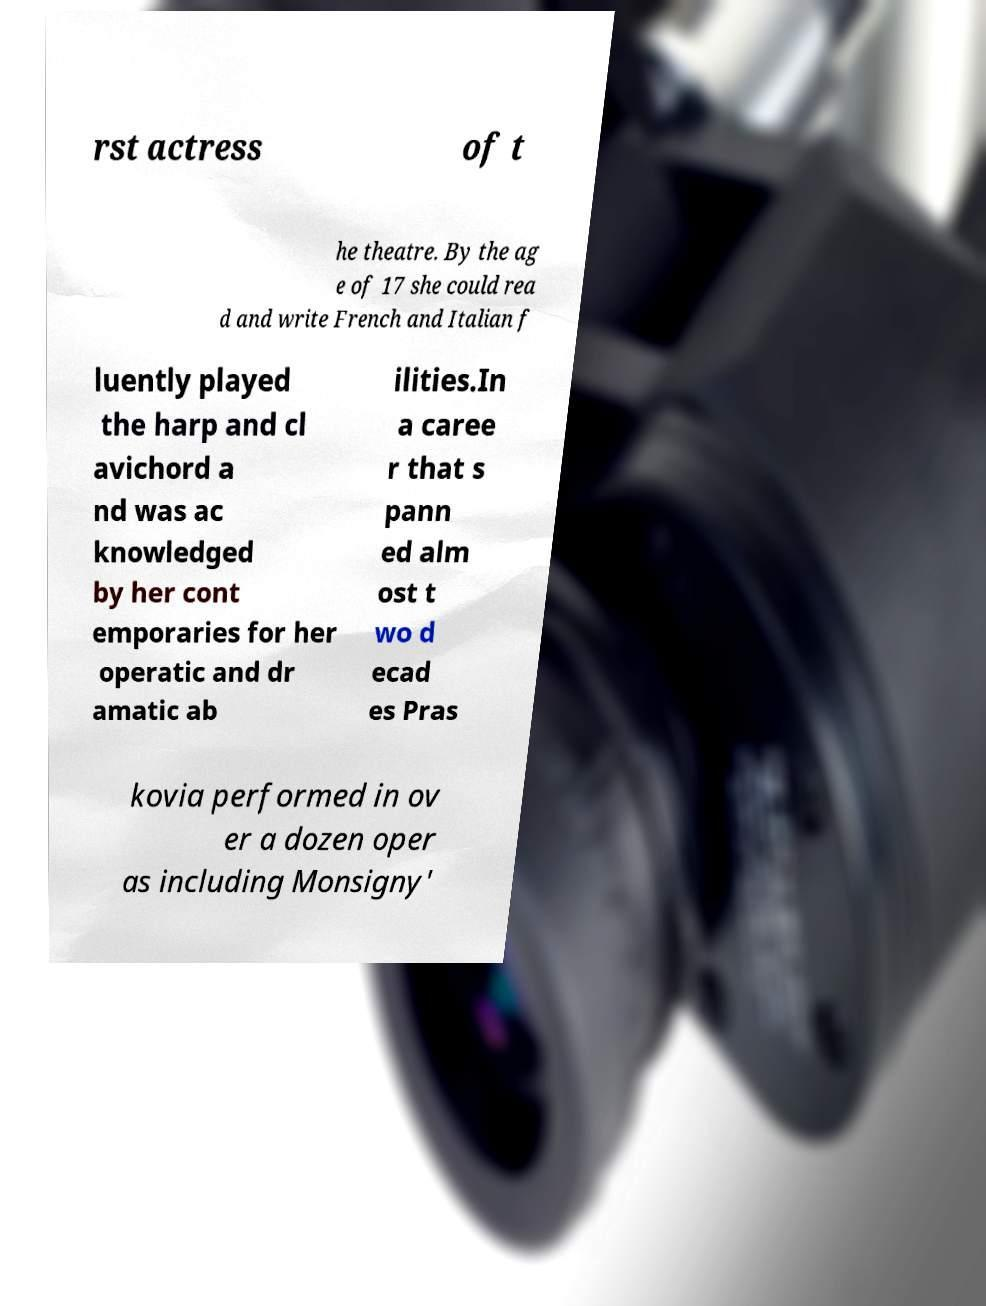Please read and relay the text visible in this image. What does it say? rst actress of t he theatre. By the ag e of 17 she could rea d and write French and Italian f luently played the harp and cl avichord a nd was ac knowledged by her cont emporaries for her operatic and dr amatic ab ilities.In a caree r that s pann ed alm ost t wo d ecad es Pras kovia performed in ov er a dozen oper as including Monsigny' 